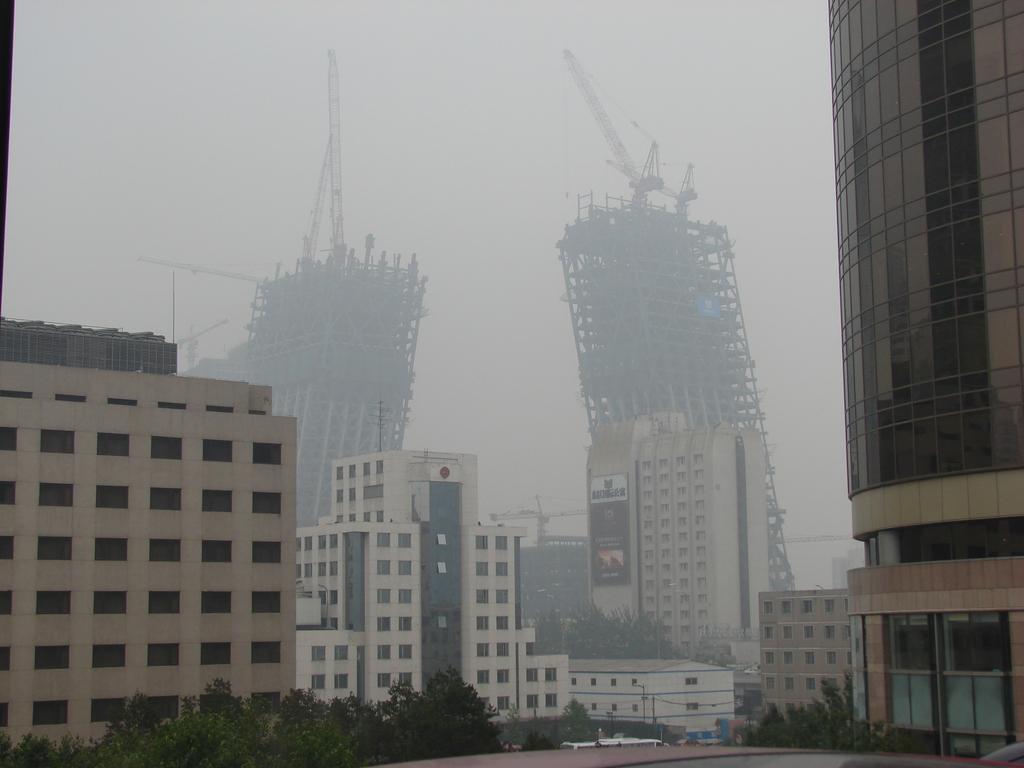Please provide a concise description of this image. In this picture we observe few buildings and in the background we observe two buildings which are about to fall. 